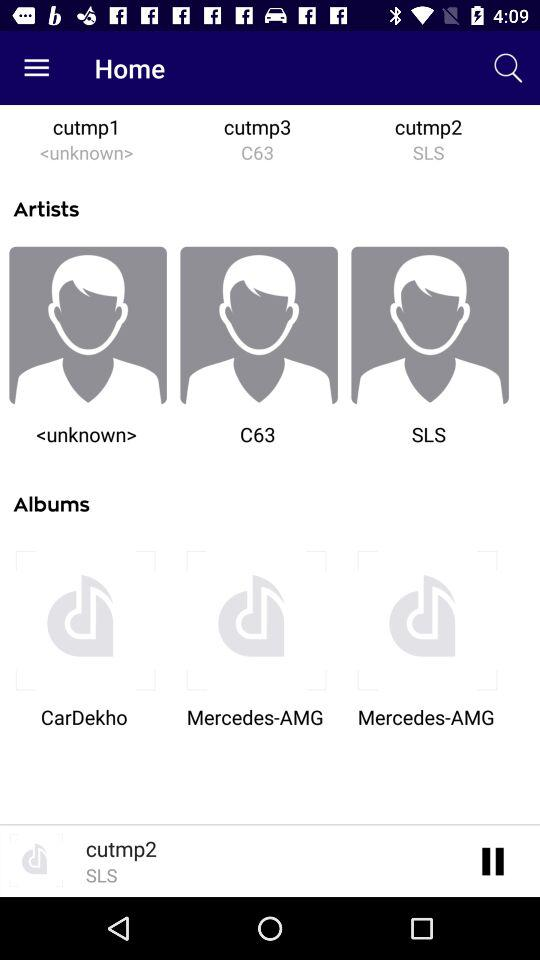What are the different album names? The different album names are: "CarDekho", "Mercedes-AMG", and "Mercedes-AMG". 